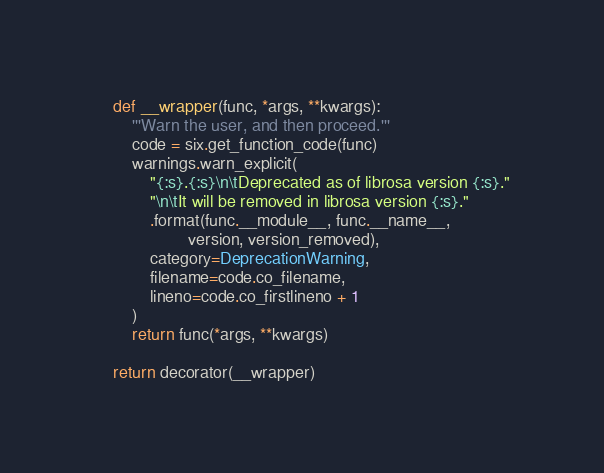<code> <loc_0><loc_0><loc_500><loc_500><_Python_>
    def __wrapper(func, *args, **kwargs):
        '''Warn the user, and then proceed.'''
        code = six.get_function_code(func)
        warnings.warn_explicit(
            "{:s}.{:s}\n\tDeprecated as of librosa version {:s}."
            "\n\tIt will be removed in librosa version {:s}."
            .format(func.__module__, func.__name__,
                    version, version_removed),
            category=DeprecationWarning,
            filename=code.co_filename,
            lineno=code.co_firstlineno + 1
        )
        return func(*args, **kwargs)

    return decorator(__wrapper)
</code> 